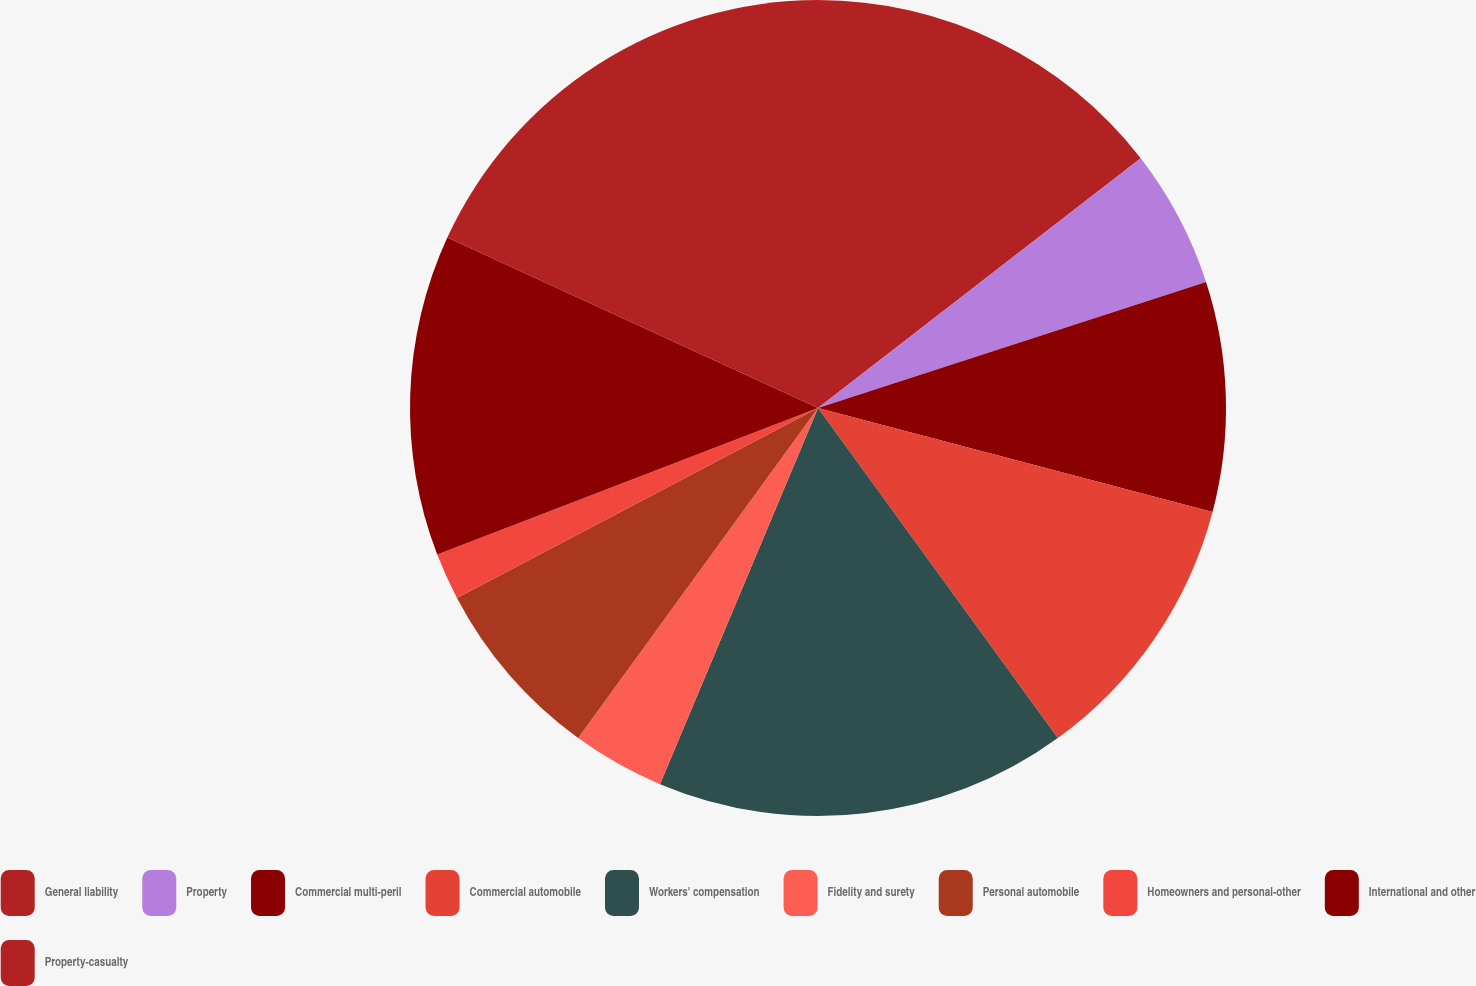<chart> <loc_0><loc_0><loc_500><loc_500><pie_chart><fcel>General liability<fcel>Property<fcel>Commercial multi-peril<fcel>Commercial automobile<fcel>Workers' compensation<fcel>Fidelity and surety<fcel>Personal automobile<fcel>Homeowners and personal-other<fcel>International and other<fcel>Property-casualty<nl><fcel>14.52%<fcel>5.48%<fcel>9.1%<fcel>10.9%<fcel>16.33%<fcel>3.67%<fcel>7.29%<fcel>1.86%<fcel>12.71%<fcel>18.14%<nl></chart> 